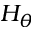<formula> <loc_0><loc_0><loc_500><loc_500>H _ { \theta }</formula> 